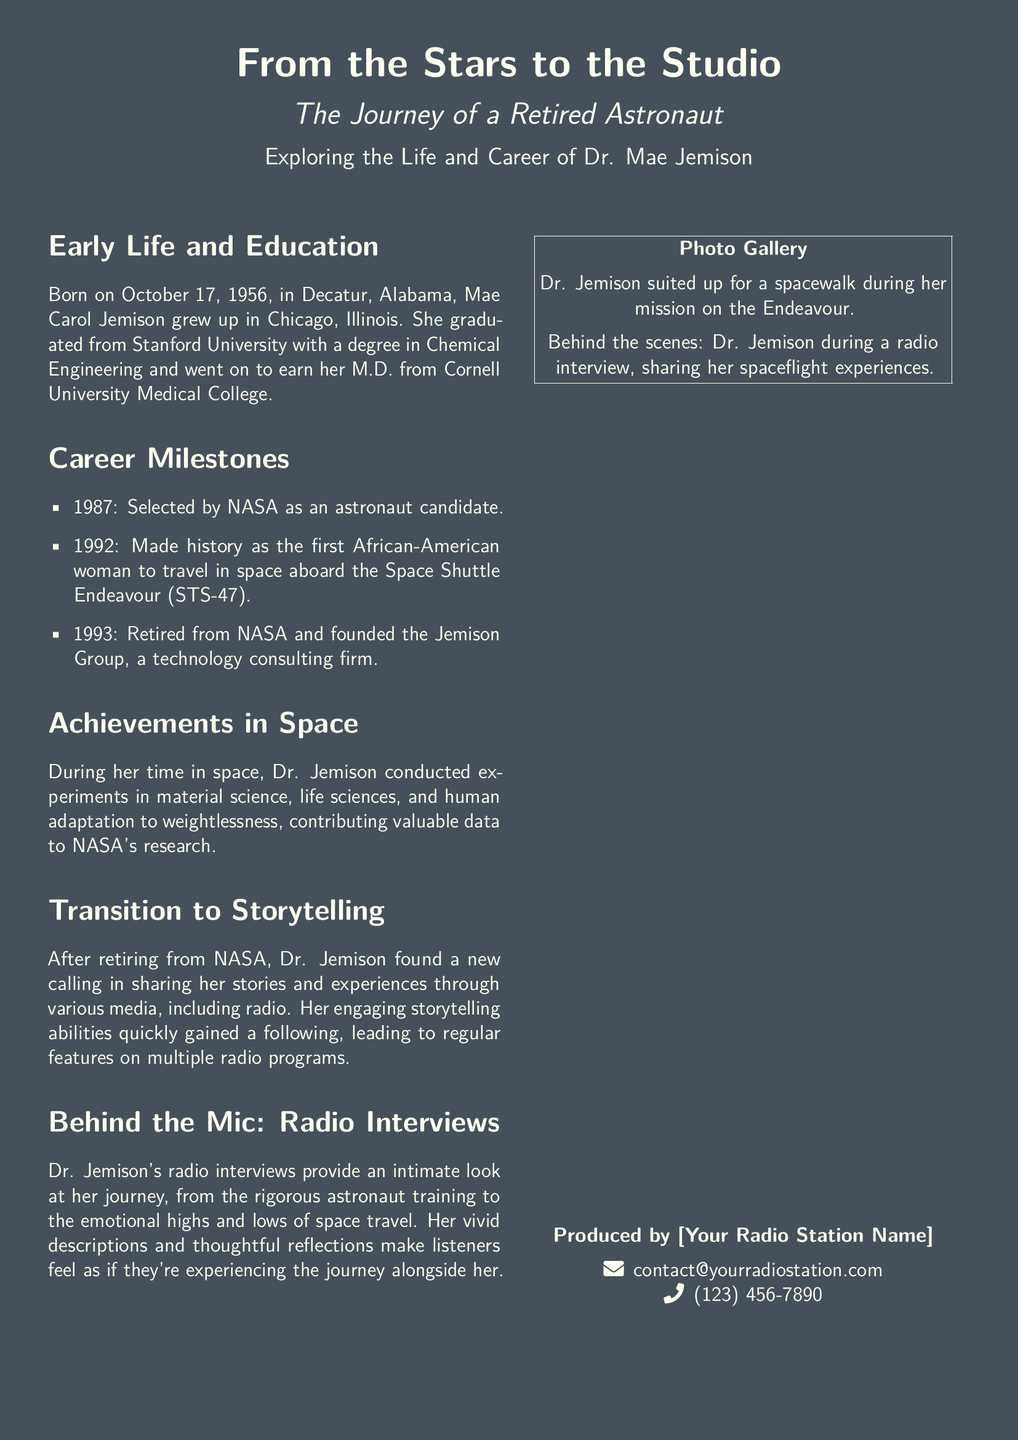what is Dr. Mae Jemison's date of birth? The document states that Dr. Mae Jemison was born on October 17, 1956.
Answer: October 17, 1956 what degree did Dr. Jemison earn from Stanford University? According to the document, she graduated with a degree in Chemical Engineering.
Answer: Chemical Engineering what historic milestone did Dr. Jemison achieve in 1992? The document notes that she made history as the first African-American woman to travel in space in 1992.
Answer: first African-American woman to travel in space what was the name of the shuttle on which Dr. Jemison flew? The article mentions that she flew aboard the Space Shuttle Endeavour (STS-47).
Answer: Space Shuttle Endeavour in what year did Dr. Jemison retire from NASA? The document indicates that she retired from NASA in 1993.
Answer: 1993 what did Dr. Jemison found after retiring from NASA? The document states that she founded the Jemison Group, a technology consulting firm.
Answer: Jemison Group what main activity has Dr. Jemison pursued after her NASA career? According to the document, she has focused on storytelling through various media, including radio.
Answer: storytelling what type of content do Dr. Jemison's radio interviews primarily provide? The document states her radio interviews provide an intimate look at her journey and experiences as an astronaut.
Answer: intimate look at her journey how does the document visually represent Dr. Jemison's experiences? The document includes a photo gallery that shows her suited up for a spacewalk and during radio interviews.
Answer: photo gallery 